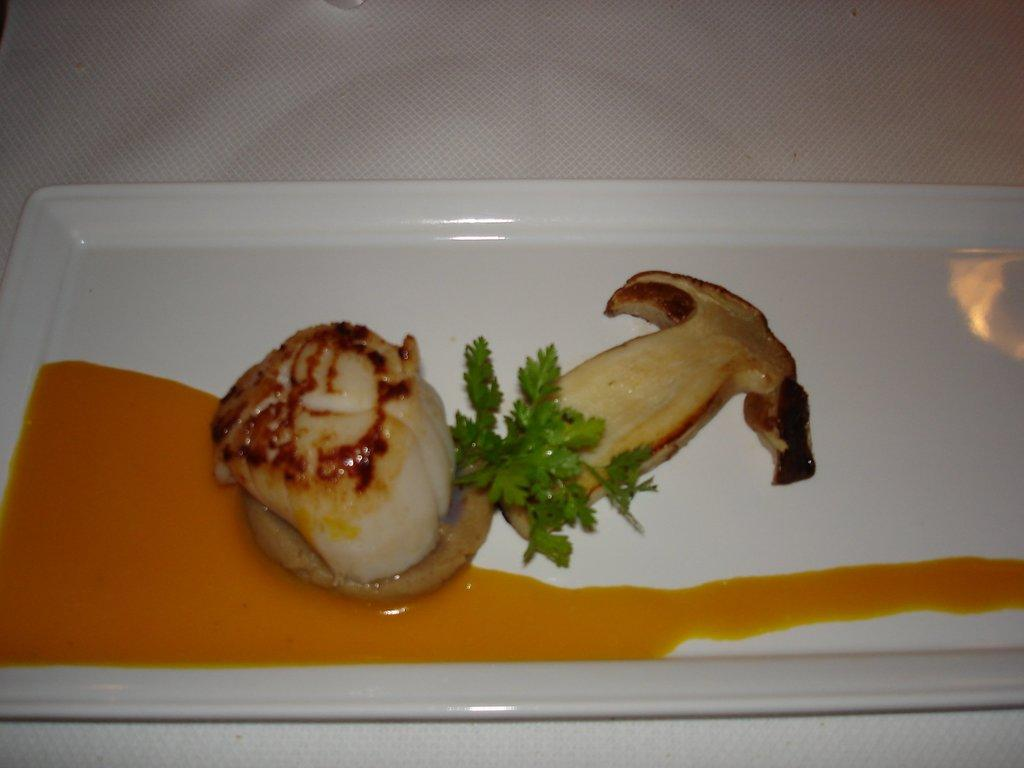What is on the plate in the image? There are food items on the plate in the image. What is located at the bottom of the image? There is tissue at the bottom of the image. What type of credit card is visible in the image? There is no credit card present in the image. Can you see a ghost in the image? There is no ghost present in the image. 